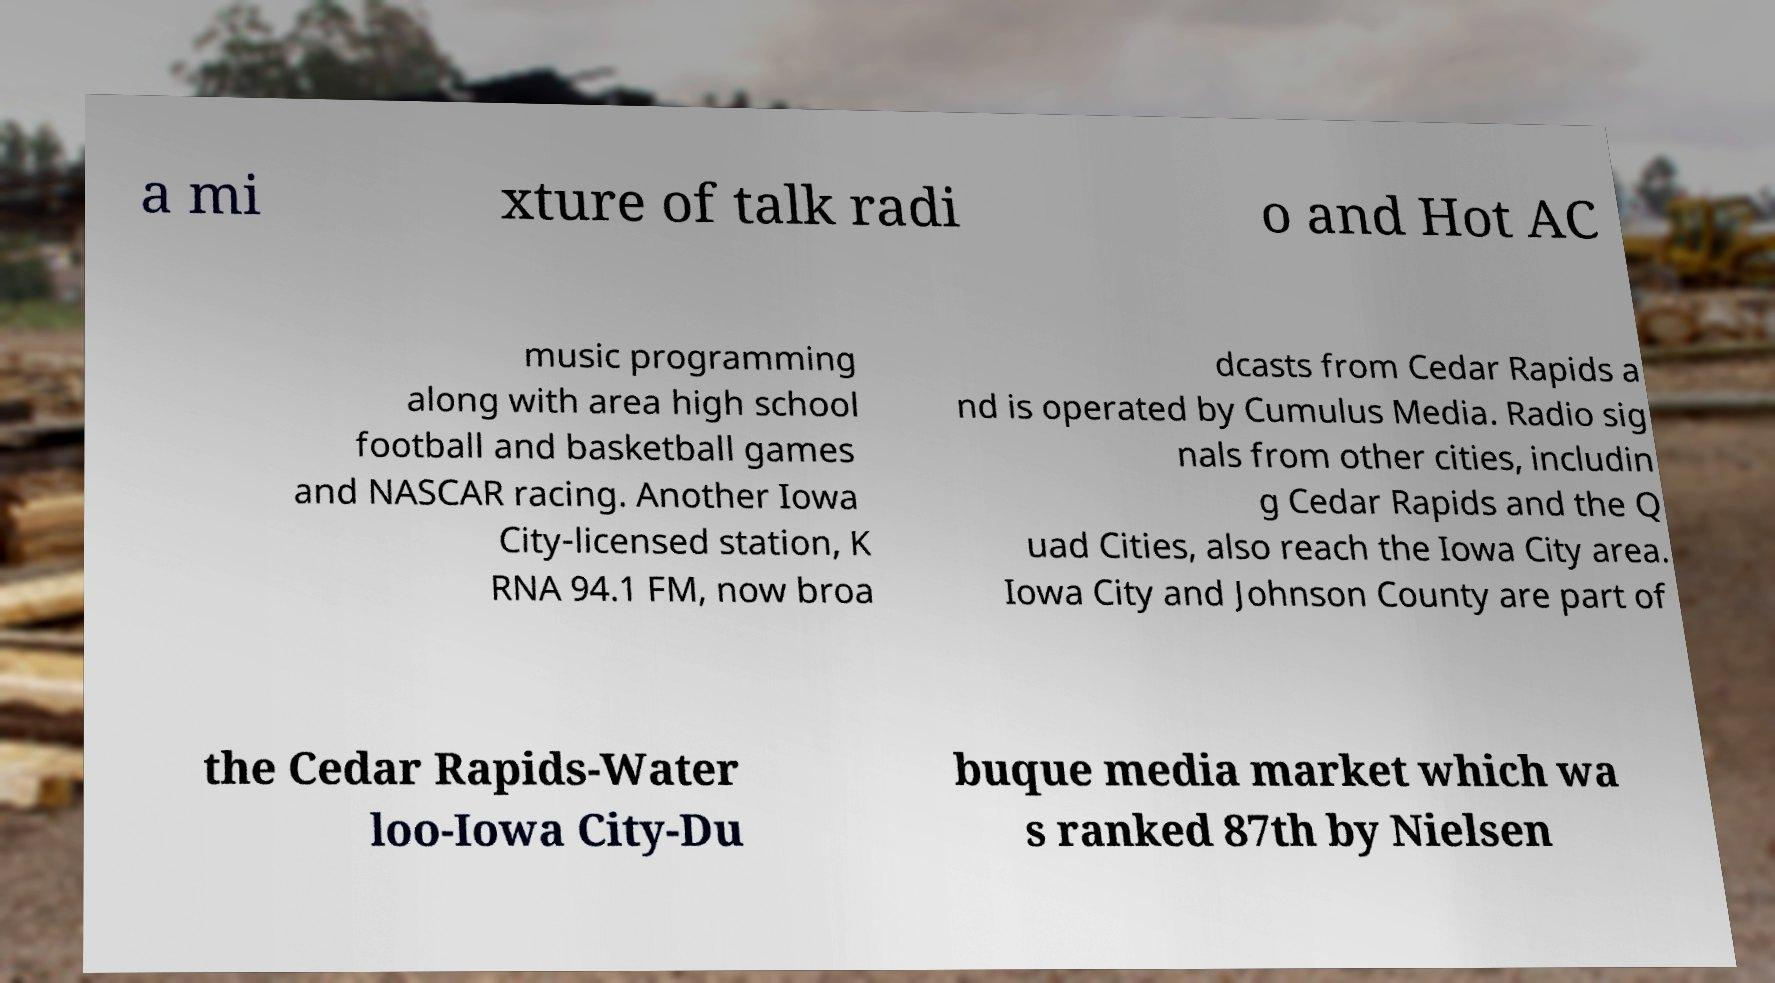There's text embedded in this image that I need extracted. Can you transcribe it verbatim? a mi xture of talk radi o and Hot AC music programming along with area high school football and basketball games and NASCAR racing. Another Iowa City-licensed station, K RNA 94.1 FM, now broa dcasts from Cedar Rapids a nd is operated by Cumulus Media. Radio sig nals from other cities, includin g Cedar Rapids and the Q uad Cities, also reach the Iowa City area. Iowa City and Johnson County are part of the Cedar Rapids-Water loo-Iowa City-Du buque media market which wa s ranked 87th by Nielsen 